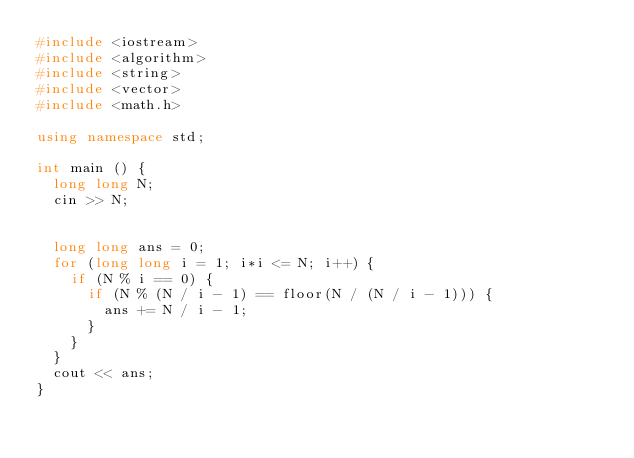<code> <loc_0><loc_0><loc_500><loc_500><_C++_>#include <iostream>
#include <algorithm>
#include <string>
#include <vector>
#include <math.h>

using namespace std;

int main () {
  long long N;
  cin >> N;
  

  long long ans = 0;
  for (long long i = 1; i*i <= N; i++) {
    if (N % i == 0) {
      if (N % (N / i - 1) == floor(N / (N / i - 1))) {
        ans += N / i - 1;
      }
    }
  }
  cout << ans;
}
</code> 